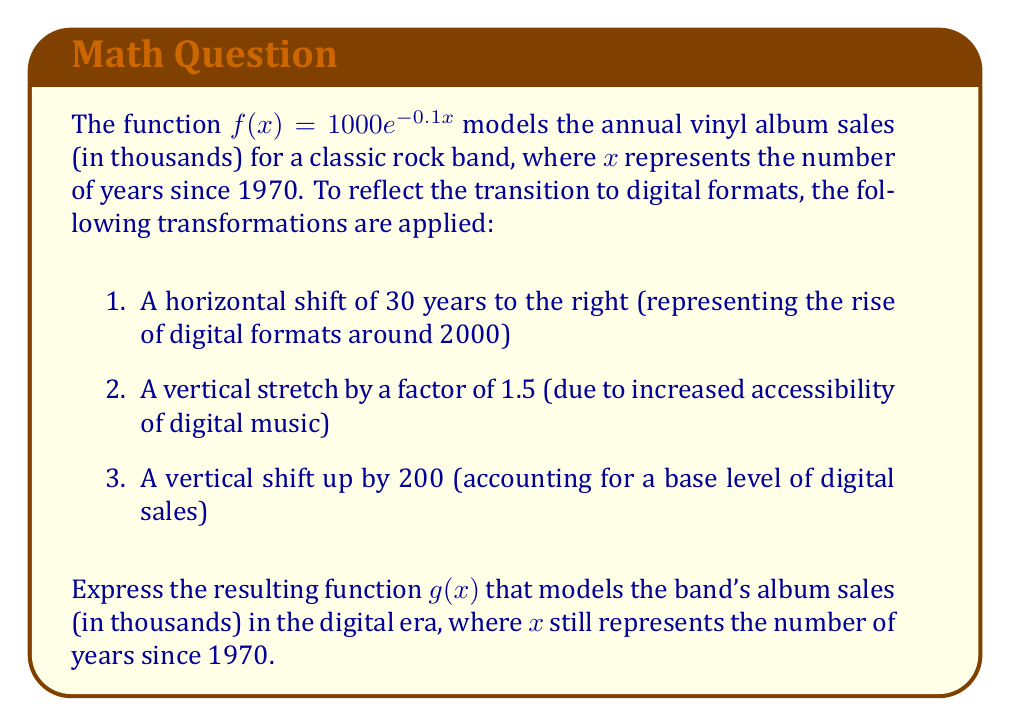Can you solve this math problem? Let's apply the transformations step by step:

1. Horizontal shift of 30 years to the right:
   $f(x-30) = 1000e^{-0.1(x-30)}$

2. Vertical stretch by a factor of 1.5:
   $1.5f(x-30) = 1.5 \cdot 1000e^{-0.1(x-30)} = 1500e^{-0.1(x-30)}$

3. Vertical shift up by 200:
   $g(x) = 1500e^{-0.1(x-30)} + 200$

Now, let's simplify the exponent:
$g(x) = 1500e^{-0.1x+3} + 200$

We can further simplify by combining the exponential terms:
$g(x) = 1500e^3 \cdot e^{-0.1x} + 200$

Calculating $e^3 \approx 20.0855$:
$g(x) = 30128.3 \cdot e^{-0.1x} + 200$

This final form represents the band's album sales (in thousands) in the digital era, where $x$ is the number of years since 1970.
Answer: $g(x) = 30128.3e^{-0.1x} + 200$ 